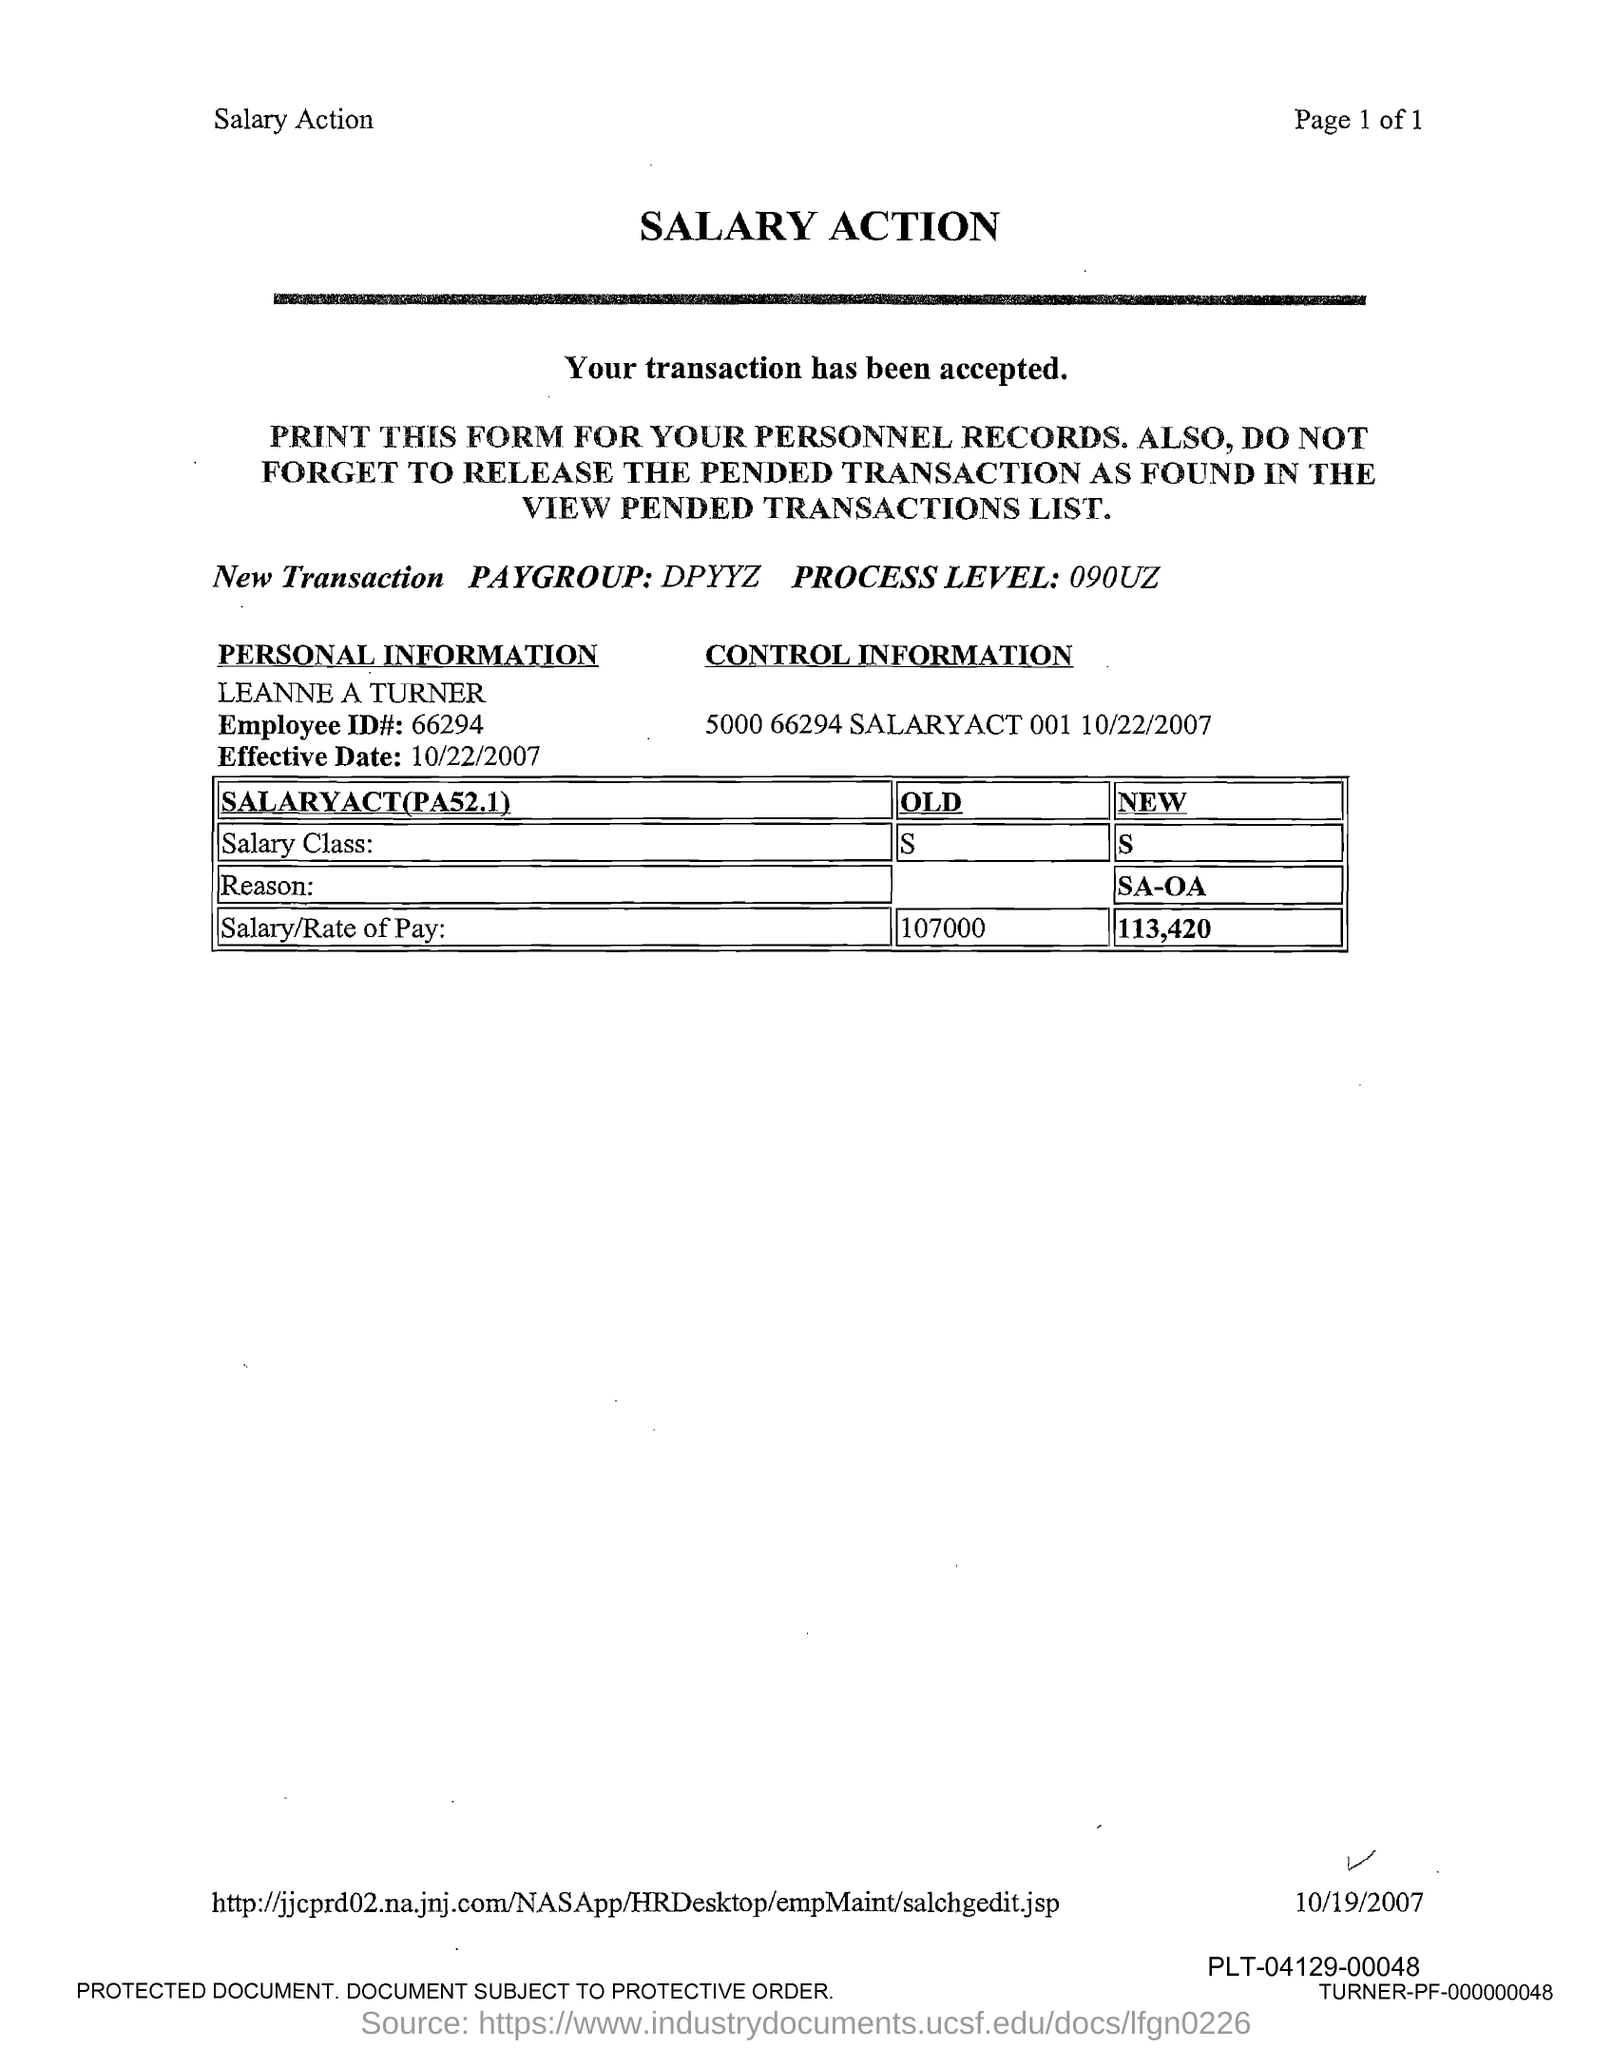Specify some key components in this picture. Leanne A Turner's new salary/rate of pay is 113,420. The Employee ID number mentioned on the form is 66294. This document is titled 'Salary Action.' The salary or rate of pay of Leanne A Turner was previously 107,000. The effective date mentioned in this form is October 22, 2007. 